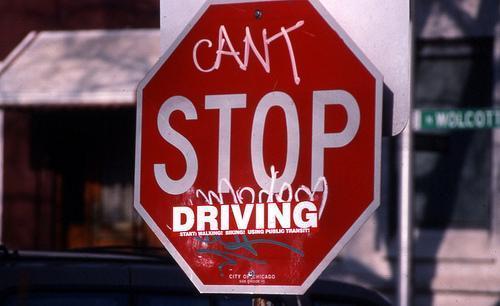How many stop signs are there?
Give a very brief answer. 1. How many yield signs are there?
Give a very brief answer. 0. 